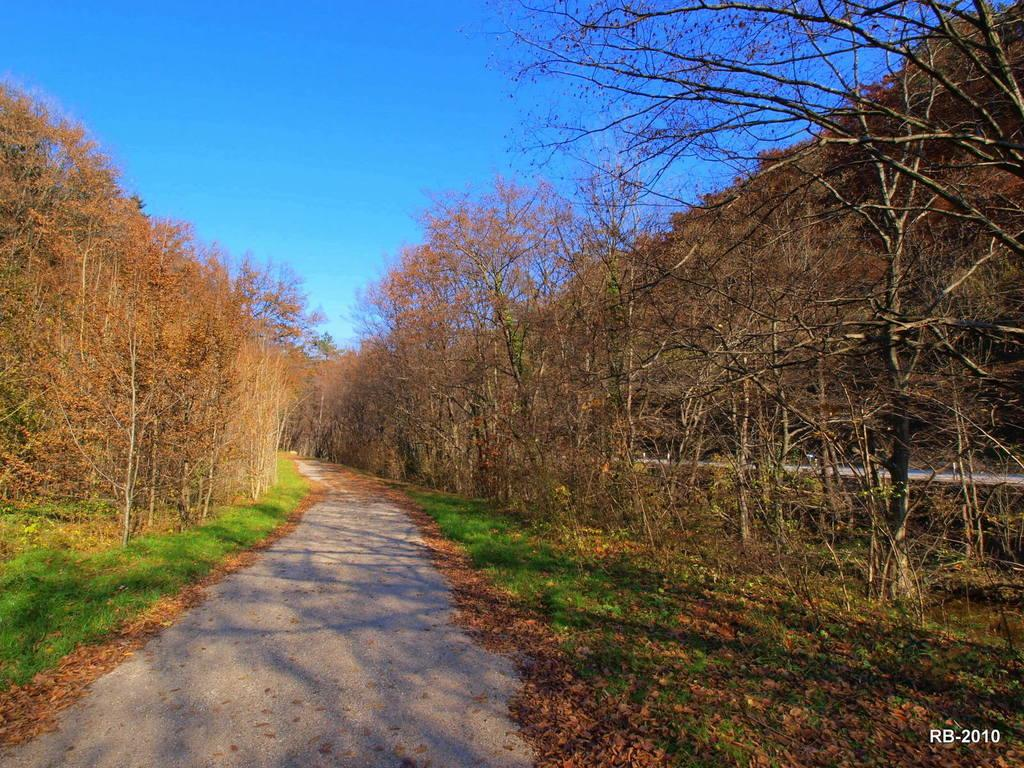What type of vegetation can be seen in the image? There are trees and grass in the image. What might be found on the ground in the image? Dried leaves are present in the image. Is there a clear path visible in the image? Yes, there is a path in the image. What is visible in the background of the image? The sky is visible in the image. Where are the alphabets and numbers located in the image? They are present in the bottom right corner of the image. What type of paper border is used around the image? There is no paper border present in the image. Who is the manager of the trees in the image? There is no manager mentioned or implied in the image. 